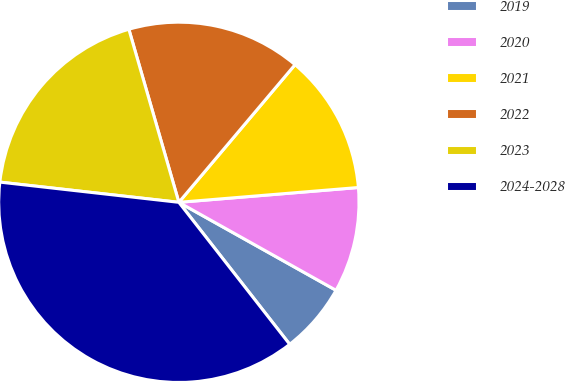Convert chart to OTSL. <chart><loc_0><loc_0><loc_500><loc_500><pie_chart><fcel>2019<fcel>2020<fcel>2021<fcel>2022<fcel>2023<fcel>2024-2028<nl><fcel>6.33%<fcel>9.43%<fcel>12.53%<fcel>15.63%<fcel>18.73%<fcel>37.33%<nl></chart> 